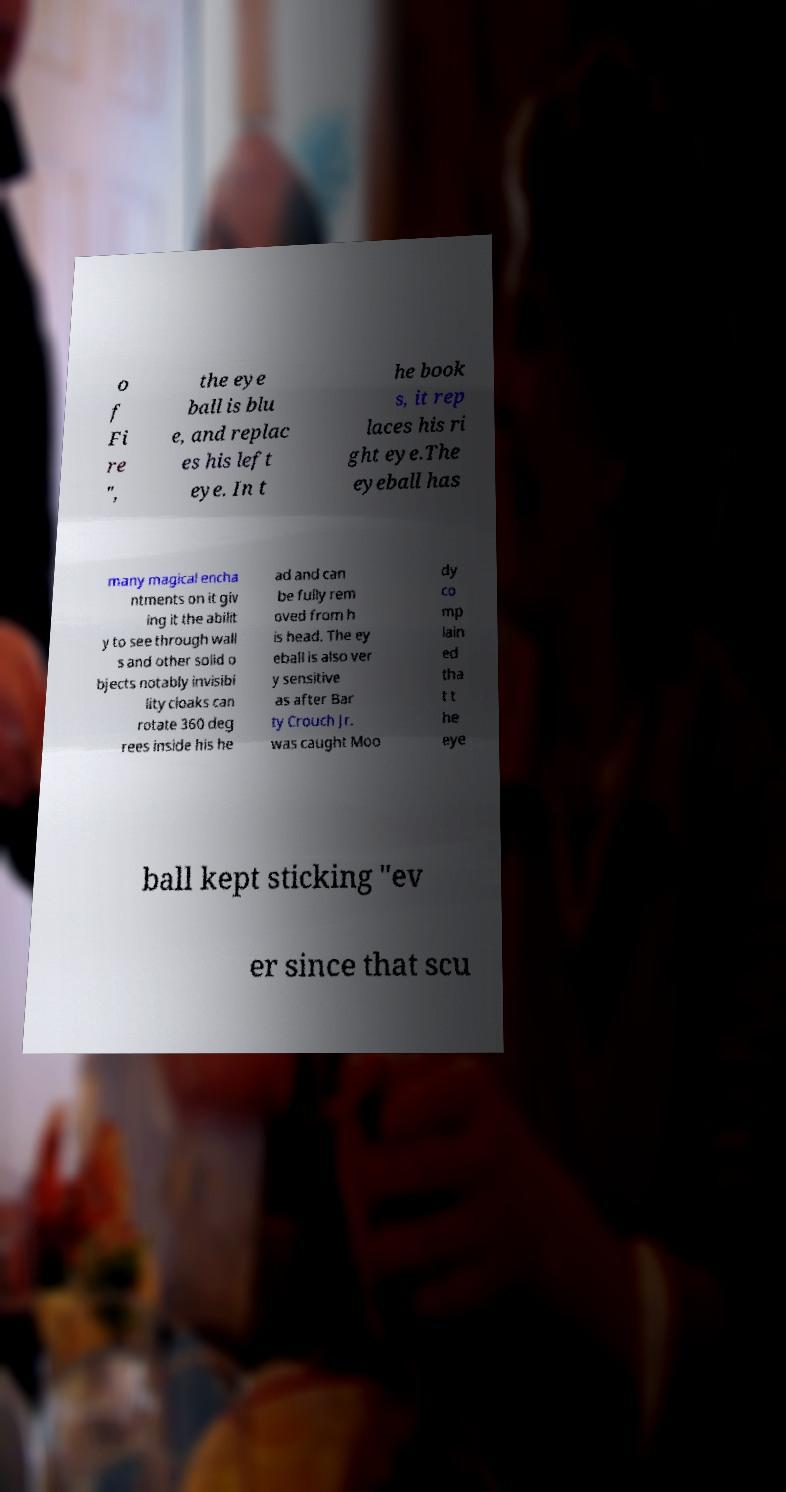What messages or text are displayed in this image? I need them in a readable, typed format. o f Fi re ", the eye ball is blu e, and replac es his left eye. In t he book s, it rep laces his ri ght eye.The eyeball has many magical encha ntments on it giv ing it the abilit y to see through wall s and other solid o bjects notably invisibi lity cloaks can rotate 360 deg rees inside his he ad and can be fully rem oved from h is head. The ey eball is also ver y sensitive as after Bar ty Crouch Jr. was caught Moo dy co mp lain ed tha t t he eye ball kept sticking "ev er since that scu 